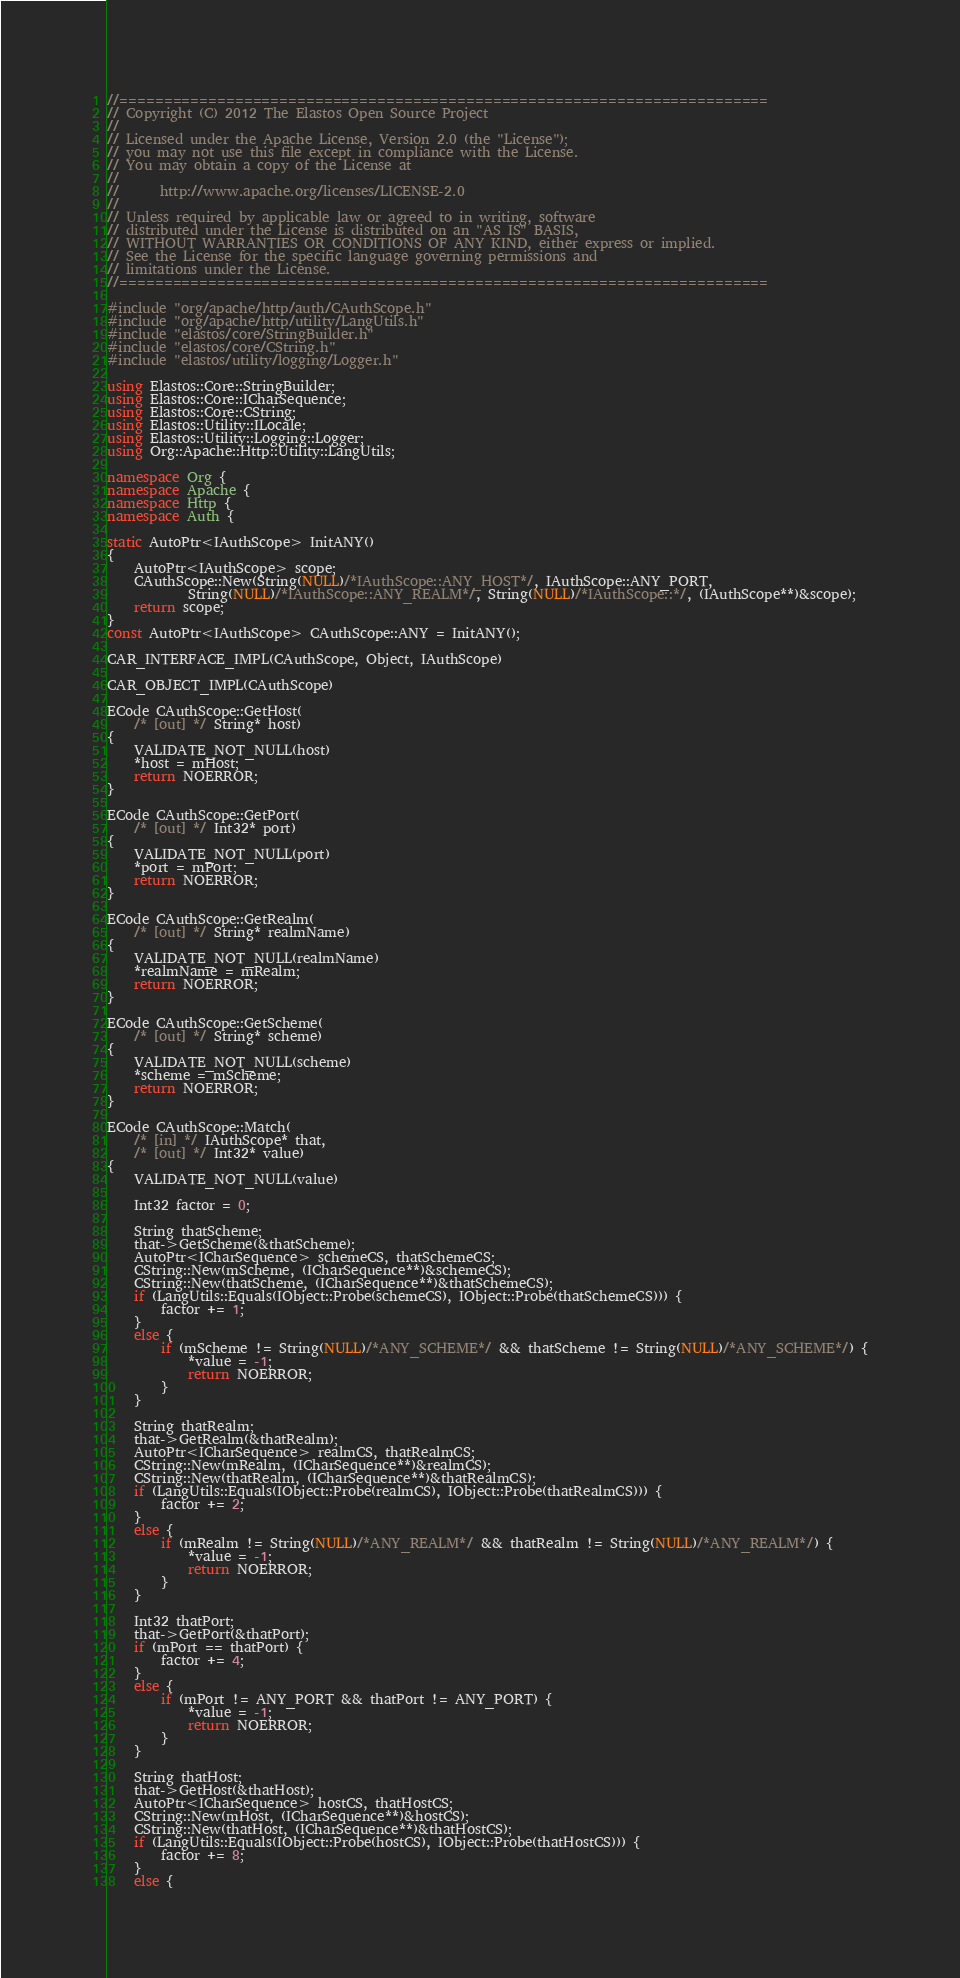<code> <loc_0><loc_0><loc_500><loc_500><_C++_>//=========================================================================
// Copyright (C) 2012 The Elastos Open Source Project
//
// Licensed under the Apache License, Version 2.0 (the "License");
// you may not use this file except in compliance with the License.
// You may obtain a copy of the License at
//
//      http://www.apache.org/licenses/LICENSE-2.0
//
// Unless required by applicable law or agreed to in writing, software
// distributed under the License is distributed on an "AS IS" BASIS,
// WITHOUT WARRANTIES OR CONDITIONS OF ANY KIND, either express or implied.
// See the License for the specific language governing permissions and
// limitations under the License.
//=========================================================================

#include "org/apache/http/auth/CAuthScope.h"
#include "org/apache/http/utility/LangUtils.h"
#include "elastos/core/StringBuilder.h"
#include "elastos/core/CString.h"
#include "elastos/utility/logging/Logger.h"

using Elastos::Core::StringBuilder;
using Elastos::Core::ICharSequence;
using Elastos::Core::CString;
using Elastos::Utility::ILocale;
using Elastos::Utility::Logging::Logger;
using Org::Apache::Http::Utility::LangUtils;

namespace Org {
namespace Apache {
namespace Http {
namespace Auth {

static AutoPtr<IAuthScope> InitANY()
{
    AutoPtr<IAuthScope> scope;
    CAuthScope::New(String(NULL)/*IAuthScope::ANY_HOST*/, IAuthScope::ANY_PORT,
            String(NULL)/*IAuthScope::ANY_REALM*/, String(NULL)/*IAuthScope::*/, (IAuthScope**)&scope);
    return scope;
}
const AutoPtr<IAuthScope> CAuthScope::ANY = InitANY();

CAR_INTERFACE_IMPL(CAuthScope, Object, IAuthScope)

CAR_OBJECT_IMPL(CAuthScope)

ECode CAuthScope::GetHost(
    /* [out] */ String* host)
{
    VALIDATE_NOT_NULL(host)
    *host = mHost;
    return NOERROR;
}

ECode CAuthScope::GetPort(
    /* [out] */ Int32* port)
{
    VALIDATE_NOT_NULL(port)
    *port = mPort;
    return NOERROR;
}

ECode CAuthScope::GetRealm(
    /* [out] */ String* realmName)
{
    VALIDATE_NOT_NULL(realmName)
    *realmName = mRealm;
    return NOERROR;
}

ECode CAuthScope::GetScheme(
    /* [out] */ String* scheme)
{
    VALIDATE_NOT_NULL(scheme)
    *scheme = mScheme;
    return NOERROR;
}

ECode CAuthScope::Match(
    /* [in] */ IAuthScope* that,
    /* [out] */ Int32* value)
{
    VALIDATE_NOT_NULL(value)

    Int32 factor = 0;

    String thatScheme;
    that->GetScheme(&thatScheme);
    AutoPtr<ICharSequence> schemeCS, thatSchemeCS;
    CString::New(mScheme, (ICharSequence**)&schemeCS);
    CString::New(thatScheme, (ICharSequence**)&thatSchemeCS);
    if (LangUtils::Equals(IObject::Probe(schemeCS), IObject::Probe(thatSchemeCS))) {
        factor += 1;
    }
    else {
        if (mScheme != String(NULL)/*ANY_SCHEME*/ && thatScheme != String(NULL)/*ANY_SCHEME*/) {
            *value = -1;
            return NOERROR;
        }
    }

    String thatRealm;
    that->GetRealm(&thatRealm);
    AutoPtr<ICharSequence> realmCS, thatRealmCS;
    CString::New(mRealm, (ICharSequence**)&realmCS);
    CString::New(thatRealm, (ICharSequence**)&thatRealmCS);
    if (LangUtils::Equals(IObject::Probe(realmCS), IObject::Probe(thatRealmCS))) {
        factor += 2;
    }
    else {
        if (mRealm != String(NULL)/*ANY_REALM*/ && thatRealm != String(NULL)/*ANY_REALM*/) {
            *value = -1;
            return NOERROR;
        }
    }

    Int32 thatPort;
    that->GetPort(&thatPort);
    if (mPort == thatPort) {
        factor += 4;
    }
    else {
        if (mPort != ANY_PORT && thatPort != ANY_PORT) {
            *value = -1;
            return NOERROR;
        }
    }

    String thatHost;
    that->GetHost(&thatHost);
    AutoPtr<ICharSequence> hostCS, thatHostCS;
    CString::New(mHost, (ICharSequence**)&hostCS);
    CString::New(thatHost, (ICharSequence**)&thatHostCS);
    if (LangUtils::Equals(IObject::Probe(hostCS), IObject::Probe(thatHostCS))) {
        factor += 8;
    }
    else {</code> 